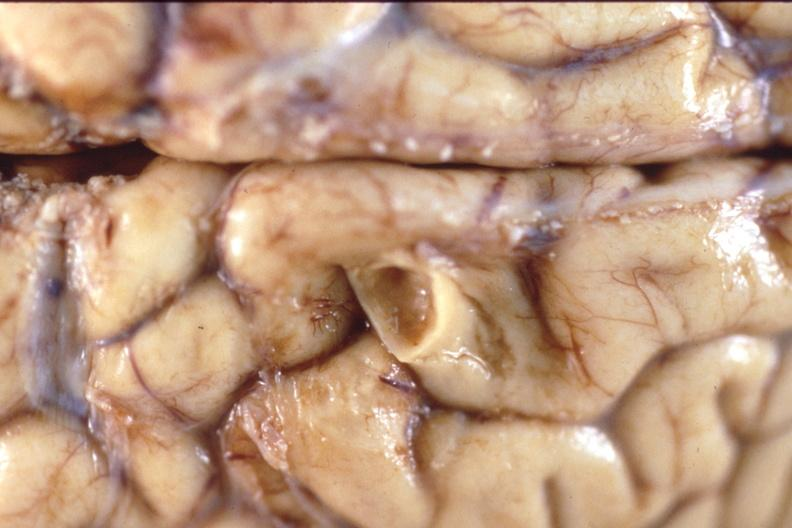does opened muscle show brain, breast cancer metastasis to meninges?
Answer the question using a single word or phrase. No 